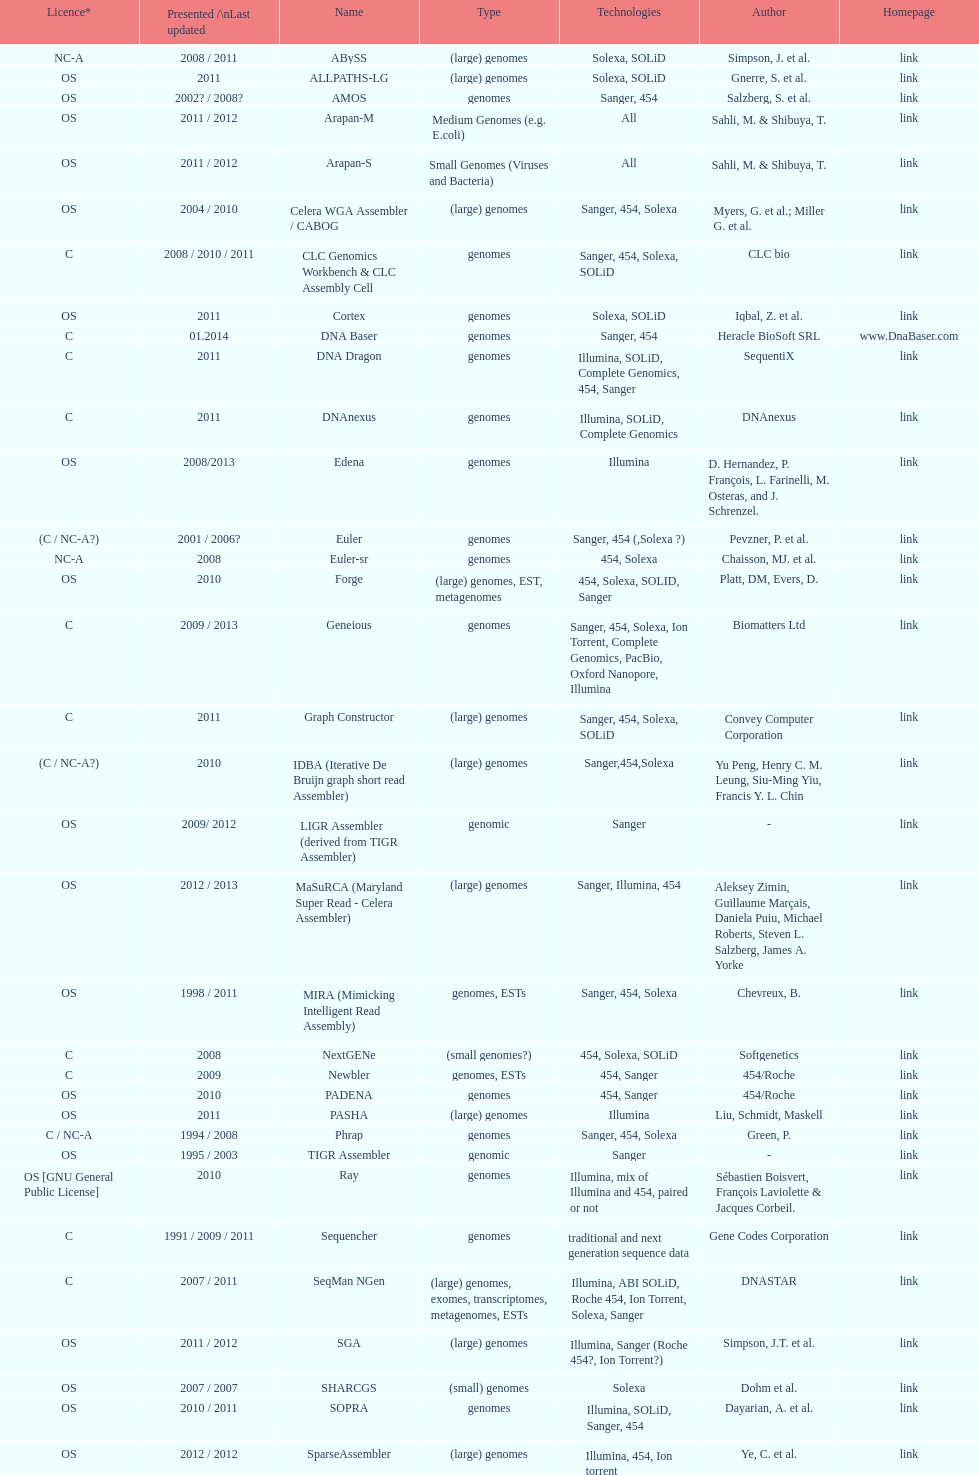When was the velvet last updated? 2009. 